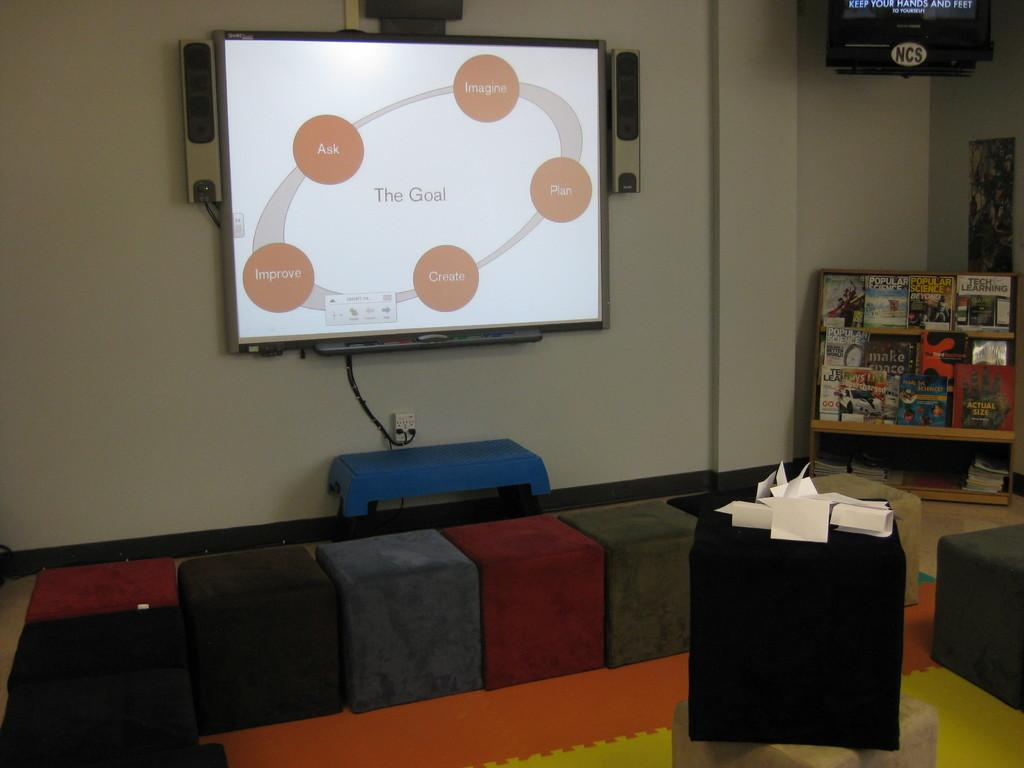What is mounted on the wall in the image? There is a TV on the wall in the image. What else can be seen on the floor in the image? The facts do not specify any other objects on the floor, so we cannot answer this question definitively. How many dogs are playing at the club in the image? There are no dogs or clubs present in the image. What type of lunch is being served in the image? There is no lunch present in the image. 